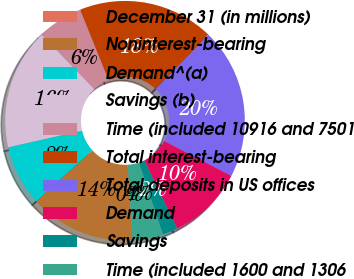Convert chart. <chart><loc_0><loc_0><loc_500><loc_500><pie_chart><fcel>December 31 (in millions)<fcel>Noninterest-bearing<fcel>Demand^(a)<fcel>Savings (b)<fcel>Time (included 10916 and 7501<fcel>Total interest-bearing<fcel>Total deposits in US offices<fcel>Demand<fcel>Savings<fcel>Time (included 1600 and 1306<nl><fcel>0.03%<fcel>14.27%<fcel>8.17%<fcel>16.31%<fcel>6.13%<fcel>18.34%<fcel>20.38%<fcel>10.2%<fcel>2.06%<fcel>4.1%<nl></chart> 